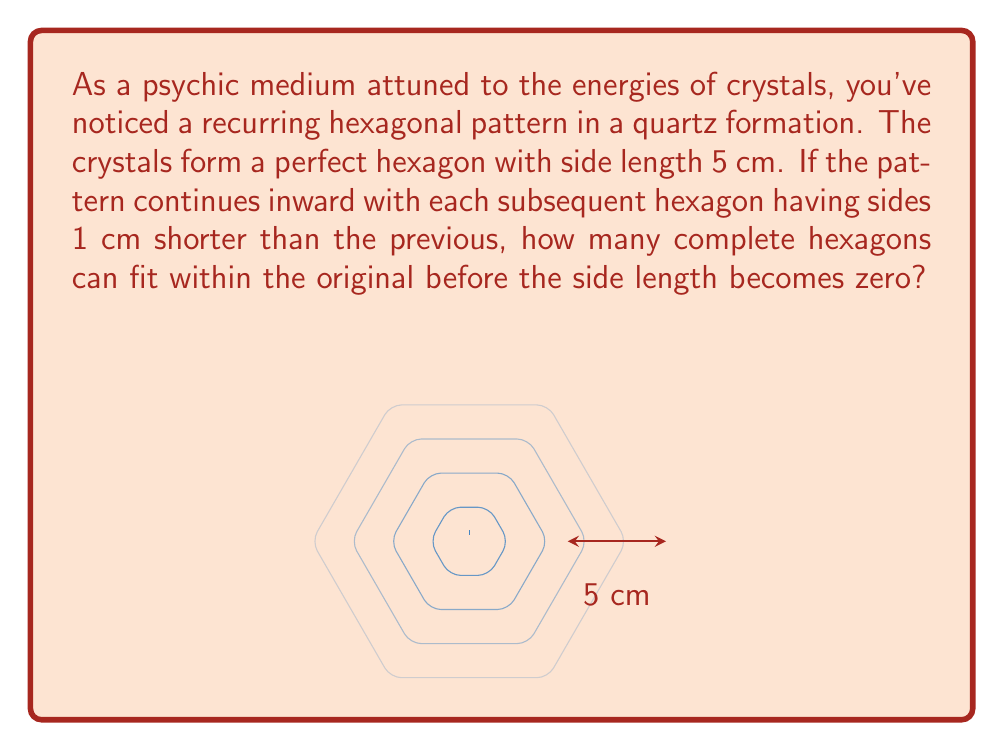Solve this math problem. Let's approach this step-by-step:

1) We start with a hexagon of side length 5 cm.

2) Each subsequent hexagon has sides 1 cm shorter than the previous one.

3) We need to find how many times we can subtract 1 from 5 before reaching 0.

4) This can be represented mathematically as:

   $$5 - 1x = 0$$

   Where $x$ is the number of times we subtract 1.

5) Solving for $x$:
   
   $$x = 5$$

6) This means we can subtract 1 a total of 5 times before reaching 0.

7) Therefore, we can fit 5 complete hexagons within the original:
   - The original hexagon with side length 5 cm
   - A hexagon with side length 4 cm
   - A hexagon with side length 3 cm
   - A hexagon with side length 2 cm
   - A hexagon with side length 1 cm

8) The next hexagon would have a side length of 0 cm, which is not a complete hexagon.

Thus, 5 complete hexagons can fit within the original before the side length becomes zero.
Answer: 5 hexagons 